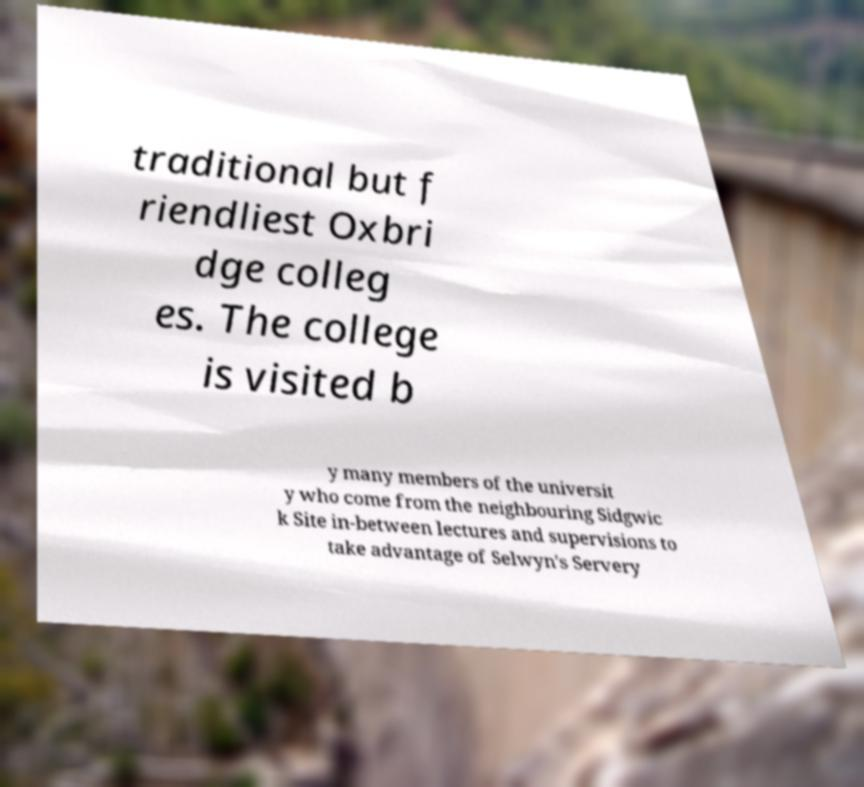Can you read and provide the text displayed in the image?This photo seems to have some interesting text. Can you extract and type it out for me? traditional but f riendliest Oxbri dge colleg es. The college is visited b y many members of the universit y who come from the neighbouring Sidgwic k Site in-between lectures and supervisions to take advantage of Selwyn's Servery 